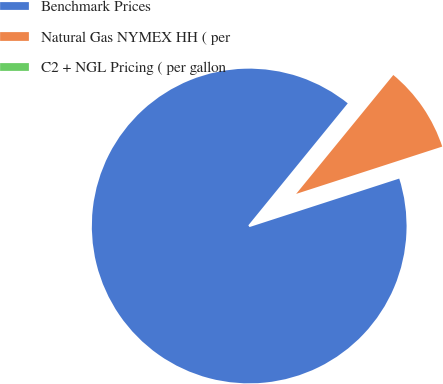<chart> <loc_0><loc_0><loc_500><loc_500><pie_chart><fcel>Benchmark Prices<fcel>Natural Gas NYMEX HH ( per<fcel>C2 + NGL Pricing ( per gallon<nl><fcel>90.87%<fcel>9.11%<fcel>0.02%<nl></chart> 